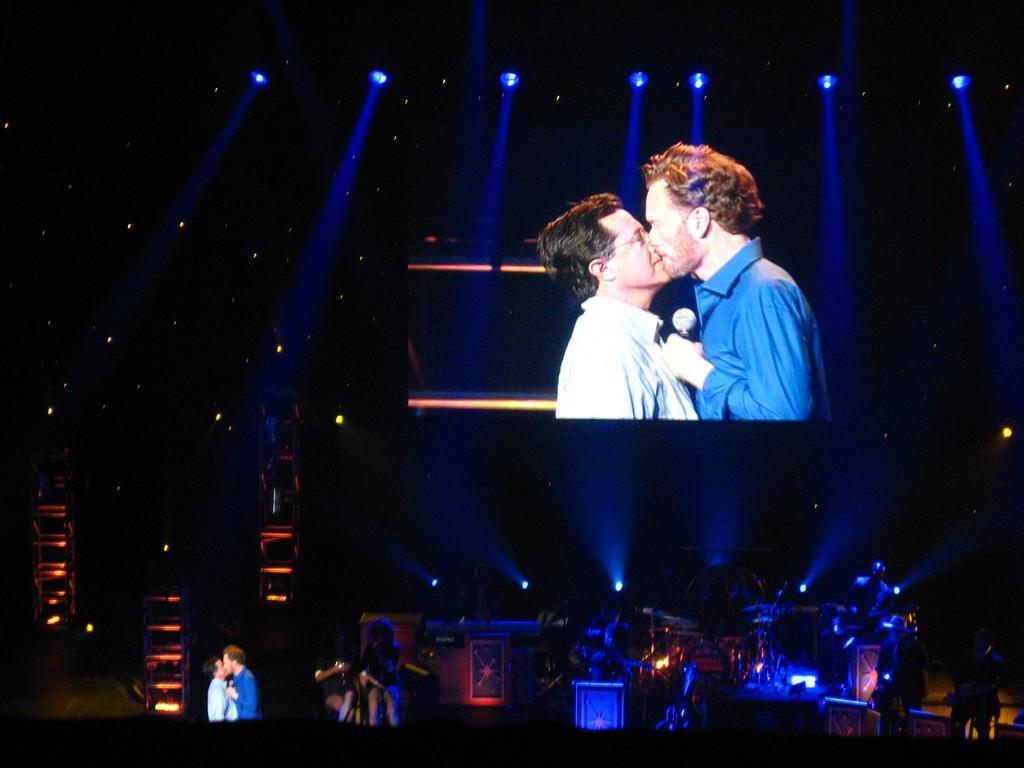Can you describe this image briefly? In this image I can see the stage on which I can see few persons and few lights and in the background I can see a huge screen and on the screen I can see two persons wearing white and blue shirts are standing and a person is holding a microphone in his hand and I can see few lights which are blue in color and the dark background. 